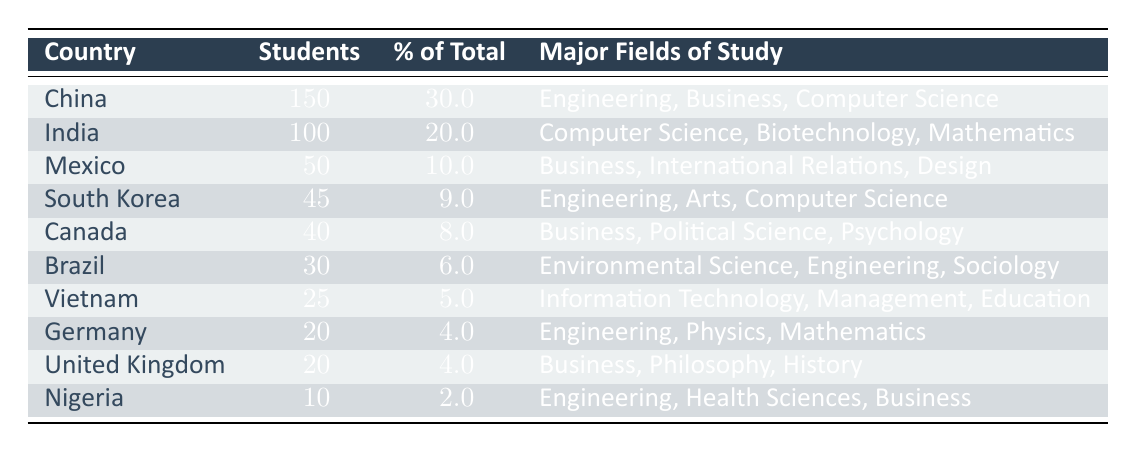What is the number of international students from China? The table indicates that the number of students from China is listed under the "NumberOfStudents" column for the corresponding row of "China." The value is 150.
Answer: 150 Which country has the highest percentage of international students? By examining the "PercentageOfTotal" column, we see that China has the highest percentage at 30.0%.
Answer: China How many countries have more than 40 international students? Counting the number of students from each country, we find that China, India, Mexico, South Korea, and Canada have more than 40 students, which totals 5 countries.
Answer: 5 Is the number of international students from Nigeria more than from Brazil? Comparing the "NumberOfStudents" for Nigeria (10) and Brazil (30) shows that Nigeria has fewer students than Brazil, making the statement false.
Answer: No What is the total number of international students from the top three countries? Adding up the number of students from the top three countries: China (150) + India (100) + Mexico (50) gives us a total of 300 students.
Answer: 300 Are there any countries listed with the same number of international students? Checking the "NumberOfStudents" column reveals that Germany and the United Kingdom both have 20 students, confirming the presence of duplicates.
Answer: Yes What is the average number of students from the countries with less than 30 students? The countries with less than 30 students are Brazil (30), Vietnam (25), Germany (20), United Kingdom (20), and Nigeria (10). Adding these gives 25 and dividing by 5 countries gives an average of 20.
Answer: 20 Which major fields of study are represented by the students from Canada and Mexico combined? The major fields for Canada are Business, Political Science, Psychology and for Mexico, it is Business, International Relations, Design. Combining these fields without duplication results in: Business, Political Science, Psychology, International Relations, Design.
Answer: Business, Political Science, Psychology, International Relations, Design 